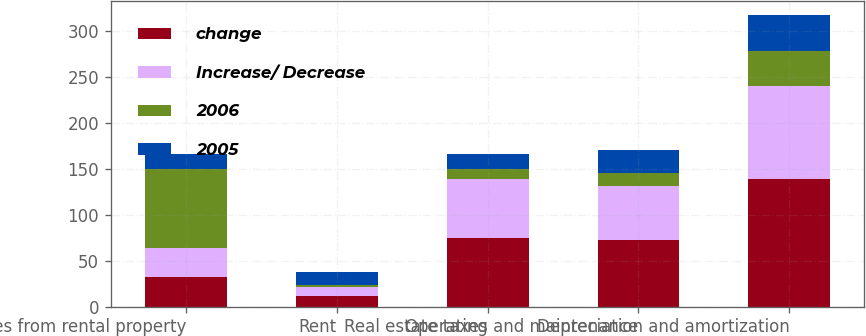Convert chart to OTSL. <chart><loc_0><loc_0><loc_500><loc_500><stacked_bar_chart><ecel><fcel>Revenues from rental property<fcel>Rent<fcel>Real estate taxes<fcel>Operating and maintenance<fcel>Depreciation and amortization<nl><fcel>change<fcel>31.75<fcel>11.5<fcel>74.6<fcel>72.7<fcel>139.3<nl><fcel>Increase/ Decrease<fcel>31.75<fcel>10<fcel>64.1<fcel>58.2<fcel>100.5<nl><fcel>2006<fcel>85.9<fcel>1.5<fcel>10.5<fcel>14.5<fcel>38.8<nl><fcel>2005<fcel>17.1<fcel>15<fcel>16.4<fcel>24.9<fcel>38.6<nl></chart> 